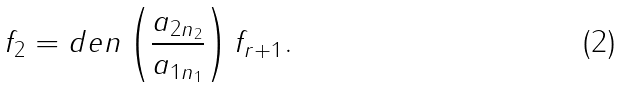Convert formula to latex. <formula><loc_0><loc_0><loc_500><loc_500>f _ { 2 } = d e n \left ( \frac { a _ { 2 n _ { 2 } } } { a _ { 1 n _ { 1 } } } \right ) f _ { r + 1 } .</formula> 